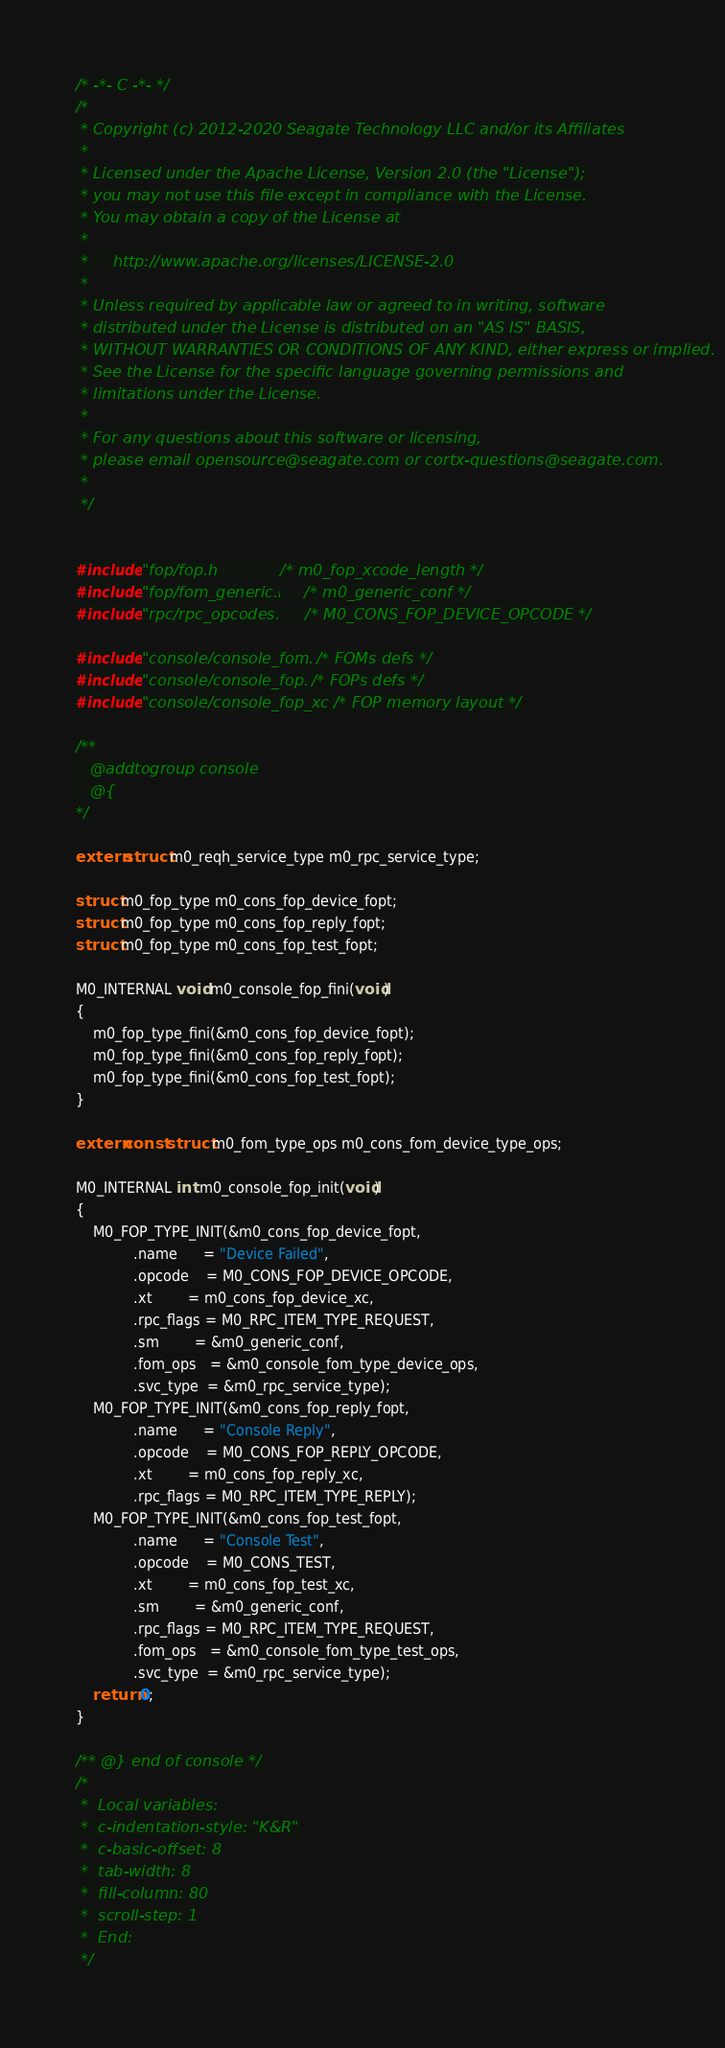<code> <loc_0><loc_0><loc_500><loc_500><_C_>/* -*- C -*- */
/*
 * Copyright (c) 2012-2020 Seagate Technology LLC and/or its Affiliates
 *
 * Licensed under the Apache License, Version 2.0 (the "License");
 * you may not use this file except in compliance with the License.
 * You may obtain a copy of the License at
 *
 *     http://www.apache.org/licenses/LICENSE-2.0
 *
 * Unless required by applicable law or agreed to in writing, software
 * distributed under the License is distributed on an "AS IS" BASIS,
 * WITHOUT WARRANTIES OR CONDITIONS OF ANY KIND, either express or implied.
 * See the License for the specific language governing permissions and
 * limitations under the License.
 *
 * For any questions about this software or licensing,
 * please email opensource@seagate.com or cortx-questions@seagate.com.
 *
 */


#include "fop/fop.h"             /* m0_fop_xcode_length */
#include "fop/fom_generic.h"     /* m0_generic_conf */
#include "rpc/rpc_opcodes.h"     /* M0_CONS_FOP_DEVICE_OPCODE */

#include "console/console_fom.h" /* FOMs defs */
#include "console/console_fop.h" /* FOPs defs */
#include "console/console_fop_xc.h" /* FOP memory layout */

/**
   @addtogroup console
   @{
*/

extern struct m0_reqh_service_type m0_rpc_service_type;

struct m0_fop_type m0_cons_fop_device_fopt;
struct m0_fop_type m0_cons_fop_reply_fopt;
struct m0_fop_type m0_cons_fop_test_fopt;

M0_INTERNAL void m0_console_fop_fini(void)
{
	m0_fop_type_fini(&m0_cons_fop_device_fopt);
	m0_fop_type_fini(&m0_cons_fop_reply_fopt);
	m0_fop_type_fini(&m0_cons_fop_test_fopt);
}

extern const struct m0_fom_type_ops m0_cons_fom_device_type_ops;

M0_INTERNAL int m0_console_fop_init(void)
{
	M0_FOP_TYPE_INIT(&m0_cons_fop_device_fopt,
			 .name      = "Device Failed",
			 .opcode    = M0_CONS_FOP_DEVICE_OPCODE,
			 .xt        = m0_cons_fop_device_xc,
			 .rpc_flags = M0_RPC_ITEM_TYPE_REQUEST,
			 .sm        = &m0_generic_conf,
			 .fom_ops   = &m0_console_fom_type_device_ops,
			 .svc_type  = &m0_rpc_service_type);
	M0_FOP_TYPE_INIT(&m0_cons_fop_reply_fopt,
			 .name      = "Console Reply",
			 .opcode    = M0_CONS_FOP_REPLY_OPCODE,
			 .xt        = m0_cons_fop_reply_xc,
			 .rpc_flags = M0_RPC_ITEM_TYPE_REPLY);
	M0_FOP_TYPE_INIT(&m0_cons_fop_test_fopt,
			 .name      = "Console Test",
			 .opcode    = M0_CONS_TEST,
			 .xt        = m0_cons_fop_test_xc,
			 .sm        = &m0_generic_conf,
			 .rpc_flags = M0_RPC_ITEM_TYPE_REQUEST,
			 .fom_ops   = &m0_console_fom_type_test_ops,
			 .svc_type  = &m0_rpc_service_type);
	return 0;
}

/** @} end of console */
/*
 *  Local variables:
 *  c-indentation-style: "K&R"
 *  c-basic-offset: 8
 *  tab-width: 8
 *  fill-column: 80
 *  scroll-step: 1
 *  End:
 */
</code> 